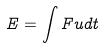Convert formula to latex. <formula><loc_0><loc_0><loc_500><loc_500>E = \int F u d t</formula> 